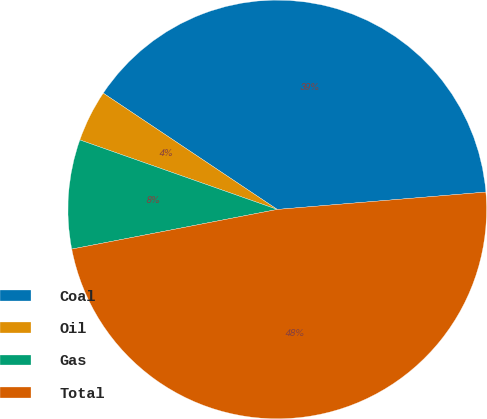Convert chart to OTSL. <chart><loc_0><loc_0><loc_500><loc_500><pie_chart><fcel>Coal<fcel>Oil<fcel>Gas<fcel>Total<nl><fcel>39.3%<fcel>3.99%<fcel>8.42%<fcel>48.29%<nl></chart> 